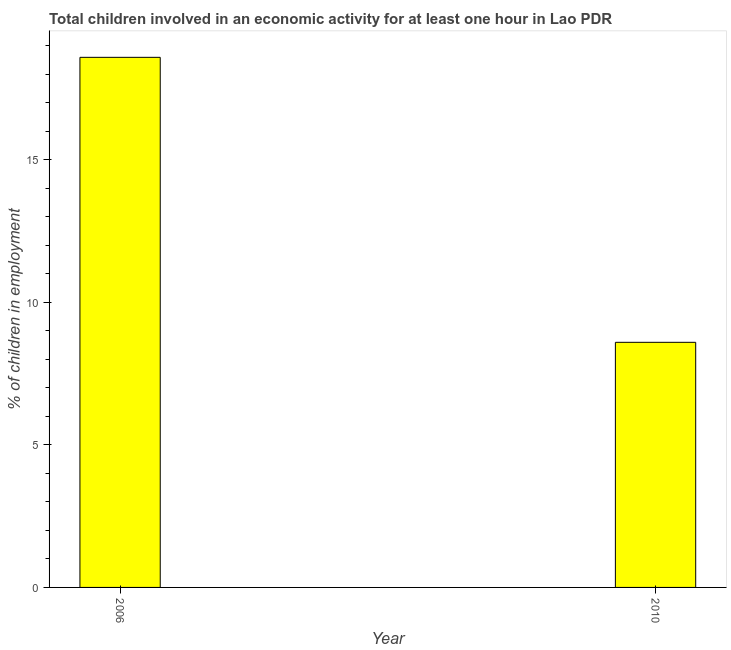Does the graph contain any zero values?
Give a very brief answer. No. What is the title of the graph?
Provide a short and direct response. Total children involved in an economic activity for at least one hour in Lao PDR. What is the label or title of the Y-axis?
Keep it short and to the point. % of children in employment. What is the percentage of children in employment in 2010?
Your answer should be very brief. 8.6. Across all years, what is the maximum percentage of children in employment?
Provide a succinct answer. 18.6. Across all years, what is the minimum percentage of children in employment?
Offer a very short reply. 8.6. In which year was the percentage of children in employment minimum?
Provide a short and direct response. 2010. What is the sum of the percentage of children in employment?
Offer a very short reply. 27.2. What is the difference between the percentage of children in employment in 2006 and 2010?
Your answer should be compact. 10. What is the average percentage of children in employment per year?
Keep it short and to the point. 13.6. What is the median percentage of children in employment?
Give a very brief answer. 13.6. In how many years, is the percentage of children in employment greater than 4 %?
Your response must be concise. 2. What is the ratio of the percentage of children in employment in 2006 to that in 2010?
Offer a very short reply. 2.16. Is the percentage of children in employment in 2006 less than that in 2010?
Give a very brief answer. No. In how many years, is the percentage of children in employment greater than the average percentage of children in employment taken over all years?
Ensure brevity in your answer.  1. What is the difference between two consecutive major ticks on the Y-axis?
Your response must be concise. 5. What is the % of children in employment in 2006?
Your answer should be compact. 18.6. What is the % of children in employment of 2010?
Provide a succinct answer. 8.6. What is the ratio of the % of children in employment in 2006 to that in 2010?
Keep it short and to the point. 2.16. 